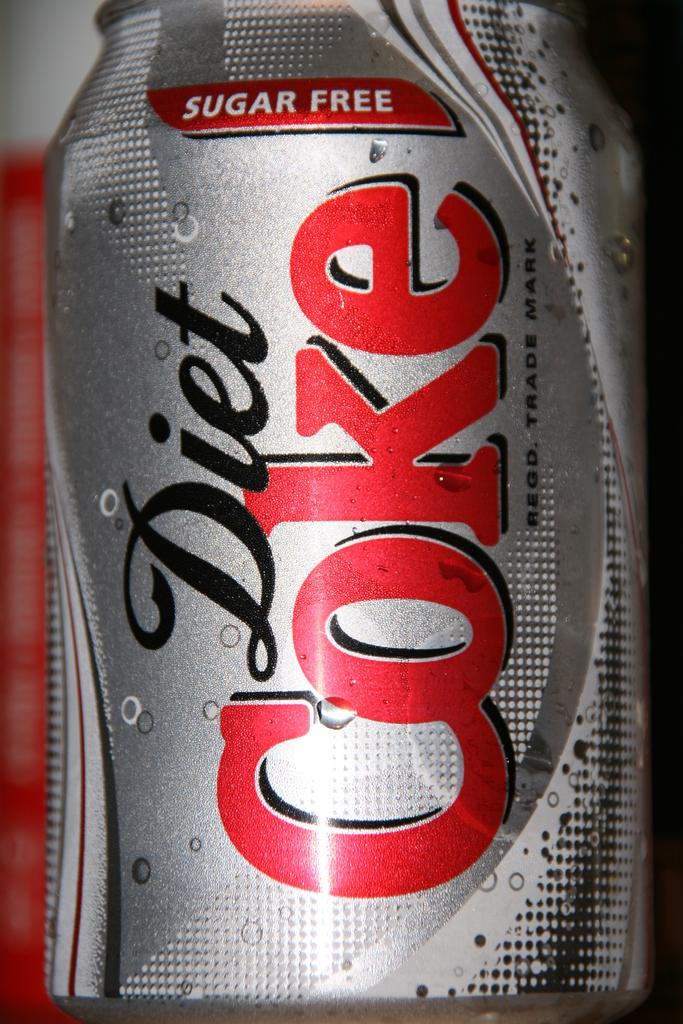<image>
Summarize the visual content of the image. A close up of a can of Diet Coke. 